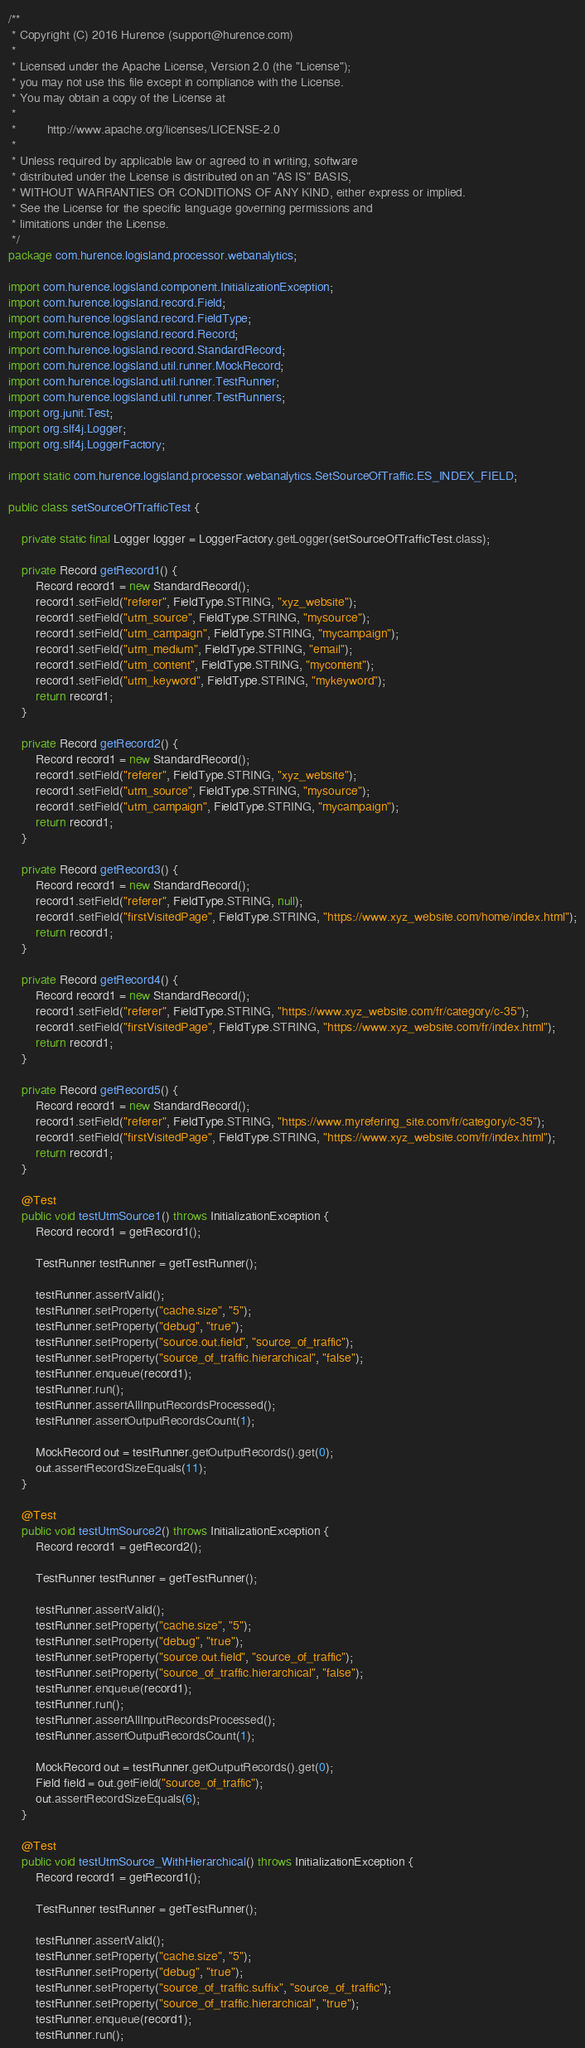<code> <loc_0><loc_0><loc_500><loc_500><_Java_>/**
 * Copyright (C) 2016 Hurence (support@hurence.com)
 *
 * Licensed under the Apache License, Version 2.0 (the "License");
 * you may not use this file except in compliance with the License.
 * You may obtain a copy of the License at
 *
 *         http://www.apache.org/licenses/LICENSE-2.0
 *
 * Unless required by applicable law or agreed to in writing, software
 * distributed under the License is distributed on an "AS IS" BASIS,
 * WITHOUT WARRANTIES OR CONDITIONS OF ANY KIND, either express or implied.
 * See the License for the specific language governing permissions and
 * limitations under the License.
 */
package com.hurence.logisland.processor.webanalytics;

import com.hurence.logisland.component.InitializationException;
import com.hurence.logisland.record.Field;
import com.hurence.logisland.record.FieldType;
import com.hurence.logisland.record.Record;
import com.hurence.logisland.record.StandardRecord;
import com.hurence.logisland.util.runner.MockRecord;
import com.hurence.logisland.util.runner.TestRunner;
import com.hurence.logisland.util.runner.TestRunners;
import org.junit.Test;
import org.slf4j.Logger;
import org.slf4j.LoggerFactory;

import static com.hurence.logisland.processor.webanalytics.SetSourceOfTraffic.ES_INDEX_FIELD;

public class setSourceOfTrafficTest {

    private static final Logger logger = LoggerFactory.getLogger(setSourceOfTrafficTest.class);

    private Record getRecord1() {
        Record record1 = new StandardRecord();
        record1.setField("referer", FieldType.STRING, "xyz_website");
        record1.setField("utm_source", FieldType.STRING, "mysource");
        record1.setField("utm_campaign", FieldType.STRING, "mycampaign");
        record1.setField("utm_medium", FieldType.STRING, "email");
        record1.setField("utm_content", FieldType.STRING, "mycontent");
        record1.setField("utm_keyword", FieldType.STRING, "mykeyword");
        return record1;
    }

    private Record getRecord2() {
        Record record1 = new StandardRecord();
        record1.setField("referer", FieldType.STRING, "xyz_website");
        record1.setField("utm_source", FieldType.STRING, "mysource");
        record1.setField("utm_campaign", FieldType.STRING, "mycampaign");
        return record1;
    }

    private Record getRecord3() {
        Record record1 = new StandardRecord();
        record1.setField("referer", FieldType.STRING, null);
        record1.setField("firstVisitedPage", FieldType.STRING, "https://www.xyz_website.com/home/index.html");
        return record1;
    }

    private Record getRecord4() {
        Record record1 = new StandardRecord();
        record1.setField("referer", FieldType.STRING, "https://www.xyz_website.com/fr/category/c-35");
        record1.setField("firstVisitedPage", FieldType.STRING, "https://www.xyz_website.com/fr/index.html");
        return record1;
    }

    private Record getRecord5() {
        Record record1 = new StandardRecord();
        record1.setField("referer", FieldType.STRING, "https://www.myrefering_site.com/fr/category/c-35");
        record1.setField("firstVisitedPage", FieldType.STRING, "https://www.xyz_website.com/fr/index.html");
        return record1;
    }

    @Test
    public void testUtmSource1() throws InitializationException {
        Record record1 = getRecord1();

        TestRunner testRunner = getTestRunner();

        testRunner.assertValid();
        testRunner.setProperty("cache.size", "5");
        testRunner.setProperty("debug", "true");
        testRunner.setProperty("source.out.field", "source_of_traffic");
        testRunner.setProperty("source_of_traffic.hierarchical", "false");
        testRunner.enqueue(record1);
        testRunner.run();
        testRunner.assertAllInputRecordsProcessed();
        testRunner.assertOutputRecordsCount(1);

        MockRecord out = testRunner.getOutputRecords().get(0);
        out.assertRecordSizeEquals(11);
    }

    @Test
    public void testUtmSource2() throws InitializationException {
        Record record1 = getRecord2();

        TestRunner testRunner = getTestRunner();

        testRunner.assertValid();
        testRunner.setProperty("cache.size", "5");
        testRunner.setProperty("debug", "true");
        testRunner.setProperty("source.out.field", "source_of_traffic");
        testRunner.setProperty("source_of_traffic.hierarchical", "false");
        testRunner.enqueue(record1);
        testRunner.run();
        testRunner.assertAllInputRecordsProcessed();
        testRunner.assertOutputRecordsCount(1);

        MockRecord out = testRunner.getOutputRecords().get(0);
        Field field = out.getField("source_of_traffic");
        out.assertRecordSizeEquals(6);
    }

    @Test
    public void testUtmSource_WithHierarchical() throws InitializationException {
        Record record1 = getRecord1();

        TestRunner testRunner = getTestRunner();

        testRunner.assertValid();
        testRunner.setProperty("cache.size", "5");
        testRunner.setProperty("debug", "true");
        testRunner.setProperty("source_of_traffic.suffix", "source_of_traffic");
        testRunner.setProperty("source_of_traffic.hierarchical", "true");
        testRunner.enqueue(record1);
        testRunner.run();</code> 